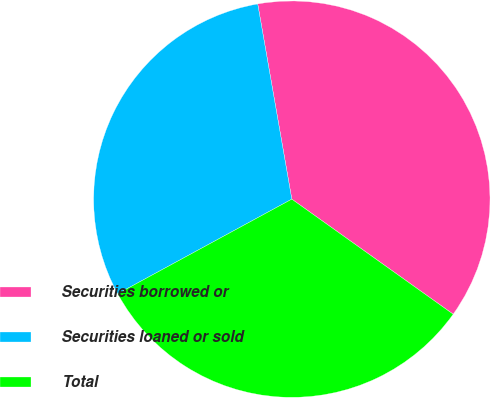<chart> <loc_0><loc_0><loc_500><loc_500><pie_chart><fcel>Securities borrowed or<fcel>Securities loaned or sold<fcel>Total<nl><fcel>37.61%<fcel>30.17%<fcel>32.22%<nl></chart> 